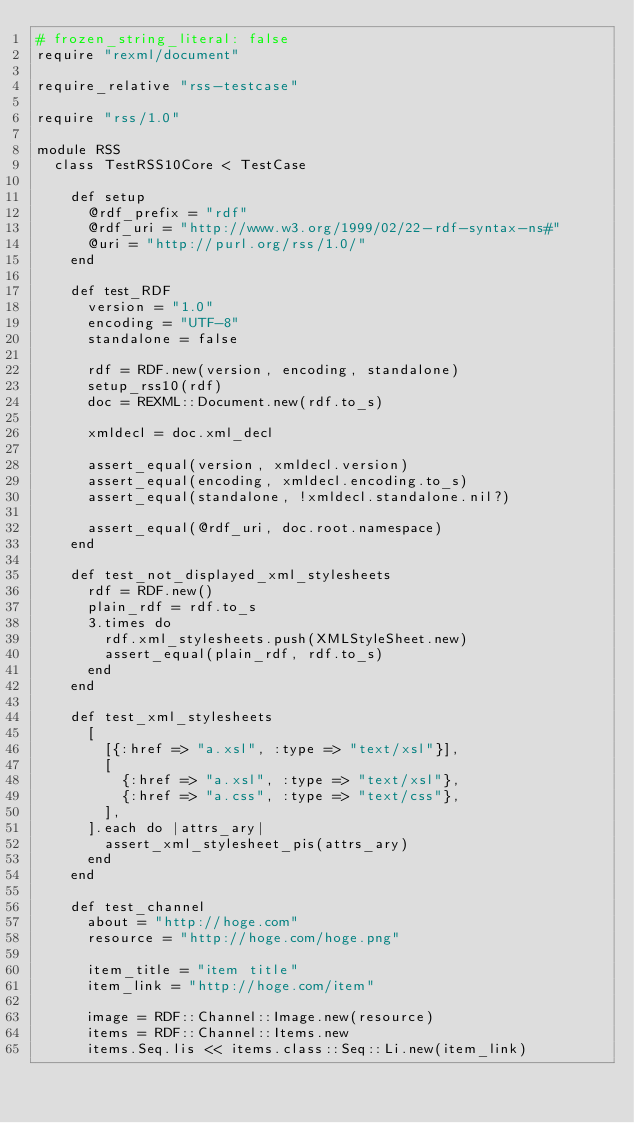<code> <loc_0><loc_0><loc_500><loc_500><_Ruby_># frozen_string_literal: false
require "rexml/document"

require_relative "rss-testcase"

require "rss/1.0"

module RSS
  class TestRSS10Core < TestCase

    def setup
      @rdf_prefix = "rdf"
      @rdf_uri = "http://www.w3.org/1999/02/22-rdf-syntax-ns#"
      @uri = "http://purl.org/rss/1.0/"
    end

    def test_RDF
      version = "1.0"
      encoding = "UTF-8"
      standalone = false

      rdf = RDF.new(version, encoding, standalone)
      setup_rss10(rdf)
      doc = REXML::Document.new(rdf.to_s)

      xmldecl = doc.xml_decl

      assert_equal(version, xmldecl.version)
      assert_equal(encoding, xmldecl.encoding.to_s)
      assert_equal(standalone, !xmldecl.standalone.nil?)

      assert_equal(@rdf_uri, doc.root.namespace)
    end

    def test_not_displayed_xml_stylesheets
      rdf = RDF.new()
      plain_rdf = rdf.to_s
      3.times do
        rdf.xml_stylesheets.push(XMLStyleSheet.new)
        assert_equal(plain_rdf, rdf.to_s)
      end
    end

    def test_xml_stylesheets
      [
        [{:href => "a.xsl", :type => "text/xsl"}],
        [
          {:href => "a.xsl", :type => "text/xsl"},
          {:href => "a.css", :type => "text/css"},
        ],
      ].each do |attrs_ary|
        assert_xml_stylesheet_pis(attrs_ary)
      end
    end

    def test_channel
      about = "http://hoge.com"
      resource = "http://hoge.com/hoge.png"

      item_title = "item title"
      item_link = "http://hoge.com/item"

      image = RDF::Channel::Image.new(resource)
      items = RDF::Channel::Items.new
      items.Seq.lis << items.class::Seq::Li.new(item_link)</code> 